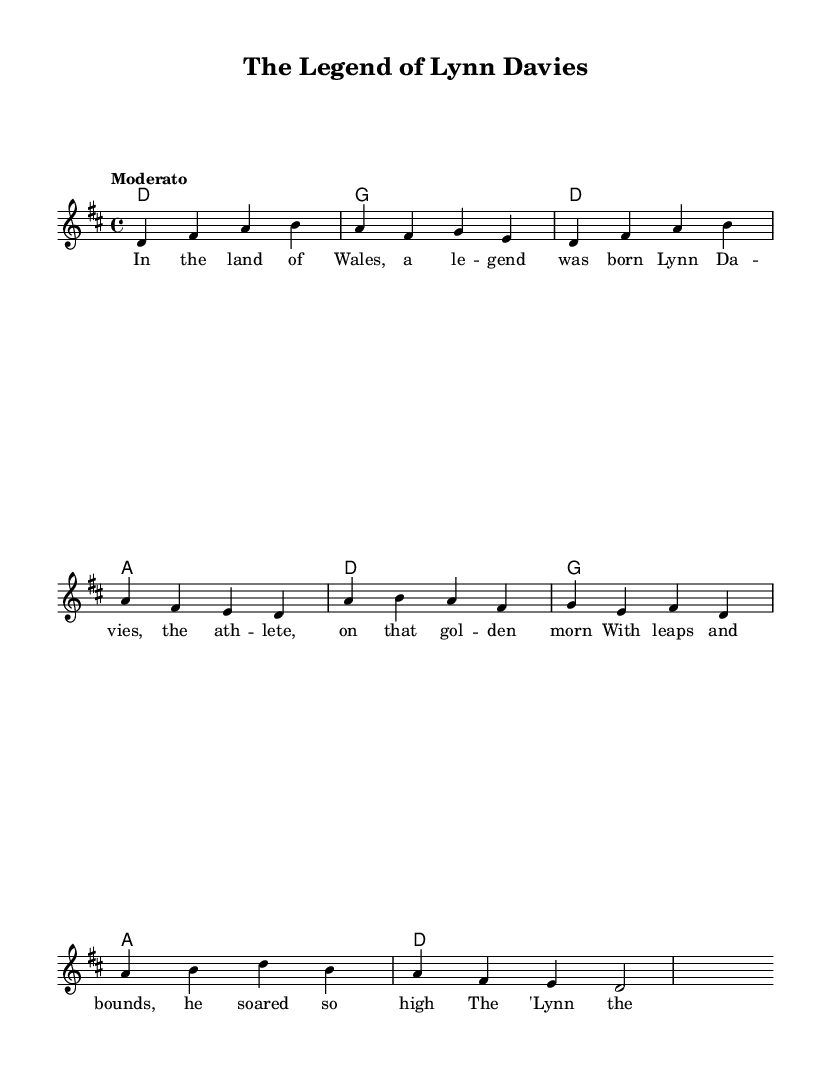What is the key signature of this music? The key signature is identified by the sharp or flat symbols at the beginning of the staff; in this case, it indicates D major, which has two sharps (F# and C#).
Answer: D major What is the time signature of the piece? The time signature is displayed as a fraction at the beginning; it shows four beats per measure, indicating a 4/4 time signature.
Answer: 4/4 What is the tempo marking for this piece? The tempo marking can be found under the title and specifies how fast the music should be played; in this case, it is marked "Moderato," meaning moderate speed.
Answer: Moderato How many measures are in the melody? By counting the individual segments separated by vertical lines known as bar lines, the melody consists of 8 measures overall.
Answer: 8 What is the title of the composition? The title appears at the top of the sheet music and identifies the work; it is "The Legend of Lynn Davies."
Answer: The Legend of Lynn Davies Which athlete is the ballad about? The lyrics contain the name of the athlete celebrated in the ballad; the text mentions "Lynn Davies," referring to the legendary Welsh athlete.
Answer: Lynn Davies What is the primary theme of the lyrics? Analyzing the lyrics, the primary theme revolves around celebrating the achievements and legend of Lynn Davies as an athlete who soared high.
Answer: Achievement 